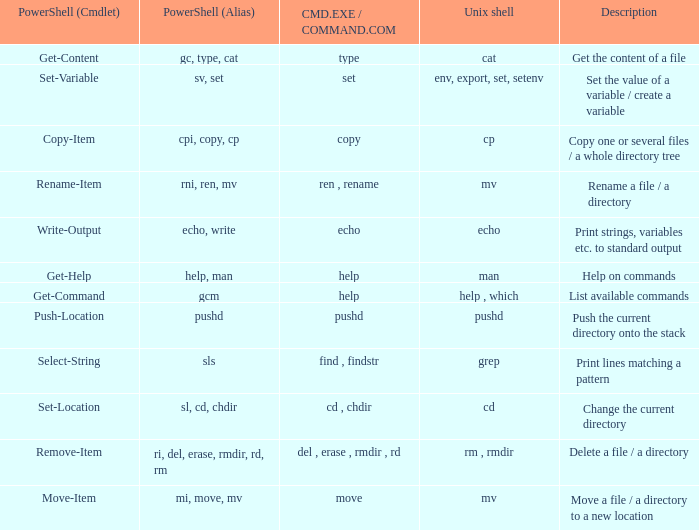Give me the full table as a dictionary. {'header': ['PowerShell (Cmdlet)', 'PowerShell (Alias)', 'CMD.EXE / COMMAND.COM', 'Unix shell', 'Description'], 'rows': [['Get-Content', 'gc, type, cat', 'type', 'cat', 'Get the content of a file'], ['Set-Variable', 'sv, set', 'set', 'env, export, set, setenv', 'Set the value of a variable / create a variable'], ['Copy-Item', 'cpi, copy, cp', 'copy', 'cp', 'Copy one or several files / a whole directory tree'], ['Rename-Item', 'rni, ren, mv', 'ren , rename', 'mv', 'Rename a file / a directory'], ['Write-Output', 'echo, write', 'echo', 'echo', 'Print strings, variables etc. to standard output'], ['Get-Help', 'help, man', 'help', 'man', 'Help on commands'], ['Get-Command', 'gcm', 'help', 'help , which', 'List available commands'], ['Push-Location', 'pushd', 'pushd', 'pushd', 'Push the current directory onto the stack'], ['Select-String', 'sls', 'find , findstr', 'grep', 'Print lines matching a pattern'], ['Set-Location', 'sl, cd, chdir', 'cd , chdir', 'cd', 'Change the current directory'], ['Remove-Item', 'ri, del, erase, rmdir, rd, rm', 'del , erase , rmdir , rd', 'rm , rmdir', 'Delete a file / a directory'], ['Move-Item', 'mi, move, mv', 'move', 'mv', 'Move a file / a directory to a new location']]} What are all values of CMD.EXE / COMMAND.COM for the unix shell echo? Echo. 